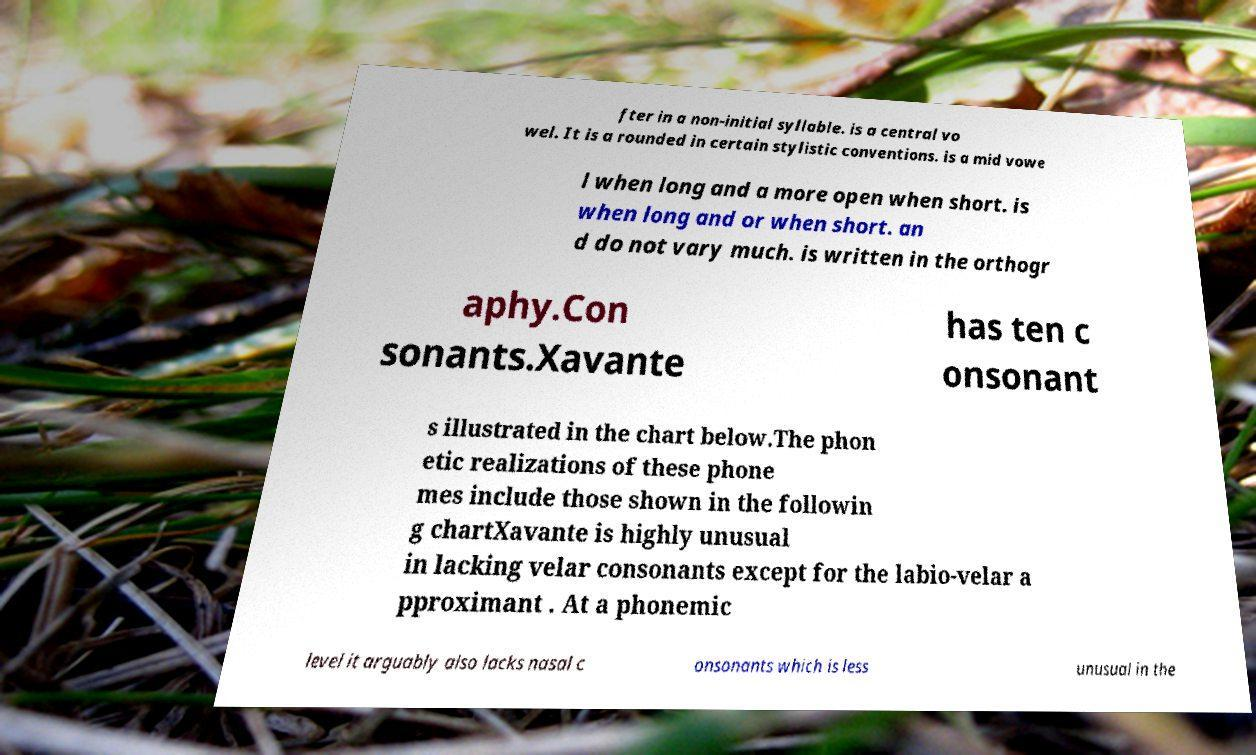There's text embedded in this image that I need extracted. Can you transcribe it verbatim? fter in a non-initial syllable. is a central vo wel. It is a rounded in certain stylistic conventions. is a mid vowe l when long and a more open when short. is when long and or when short. an d do not vary much. is written in the orthogr aphy.Con sonants.Xavante has ten c onsonant s illustrated in the chart below.The phon etic realizations of these phone mes include those shown in the followin g chartXavante is highly unusual in lacking velar consonants except for the labio-velar a pproximant . At a phonemic level it arguably also lacks nasal c onsonants which is less unusual in the 